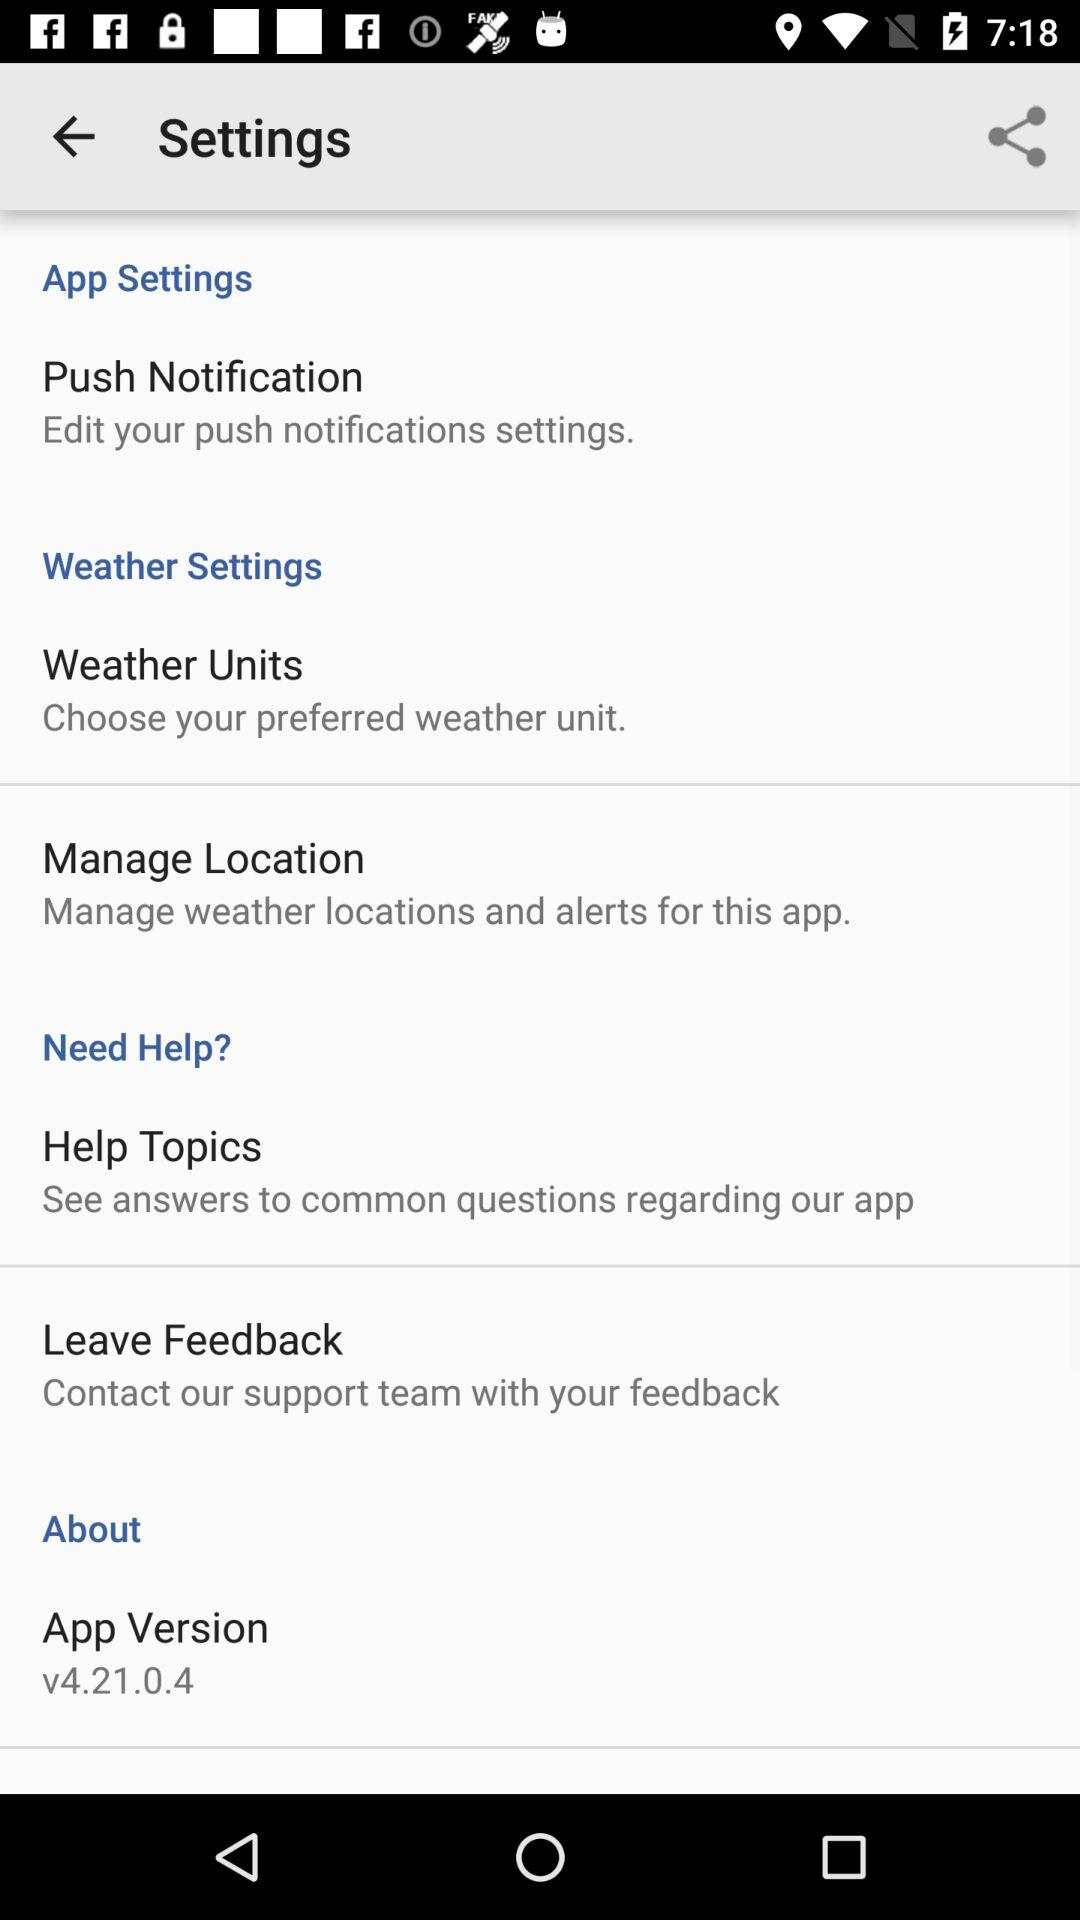Which weather unit is preferred?
When the provided information is insufficient, respond with <no answer>. <no answer> 